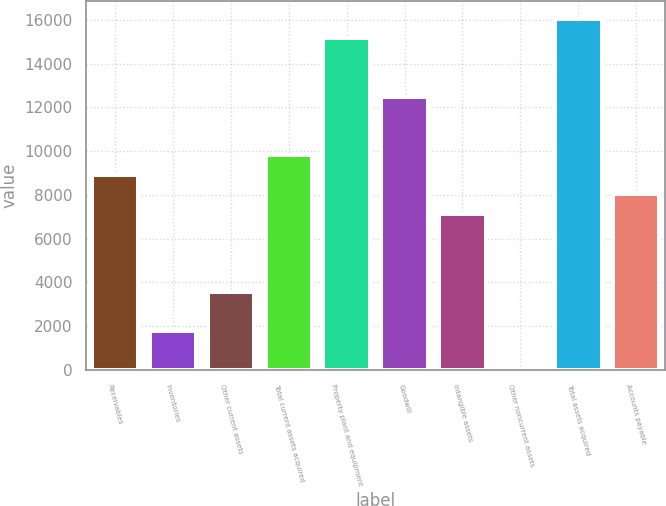Convert chart to OTSL. <chart><loc_0><loc_0><loc_500><loc_500><bar_chart><fcel>Receivables<fcel>Inventories<fcel>Other current assets<fcel>Total current assets acquired<fcel>Property plant and equipment<fcel>Goodwill<fcel>Intangible assets<fcel>Other noncurrent assets<fcel>Total assets acquired<fcel>Accounts payable<nl><fcel>8924<fcel>1792.8<fcel>3575.6<fcel>9815.4<fcel>15163.8<fcel>12489.6<fcel>7141.2<fcel>10<fcel>16055.2<fcel>8032.6<nl></chart> 